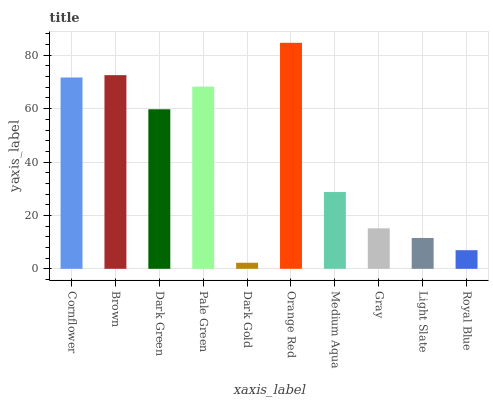Is Dark Gold the minimum?
Answer yes or no. Yes. Is Orange Red the maximum?
Answer yes or no. Yes. Is Brown the minimum?
Answer yes or no. No. Is Brown the maximum?
Answer yes or no. No. Is Brown greater than Cornflower?
Answer yes or no. Yes. Is Cornflower less than Brown?
Answer yes or no. Yes. Is Cornflower greater than Brown?
Answer yes or no. No. Is Brown less than Cornflower?
Answer yes or no. No. Is Dark Green the high median?
Answer yes or no. Yes. Is Medium Aqua the low median?
Answer yes or no. Yes. Is Light Slate the high median?
Answer yes or no. No. Is Brown the low median?
Answer yes or no. No. 